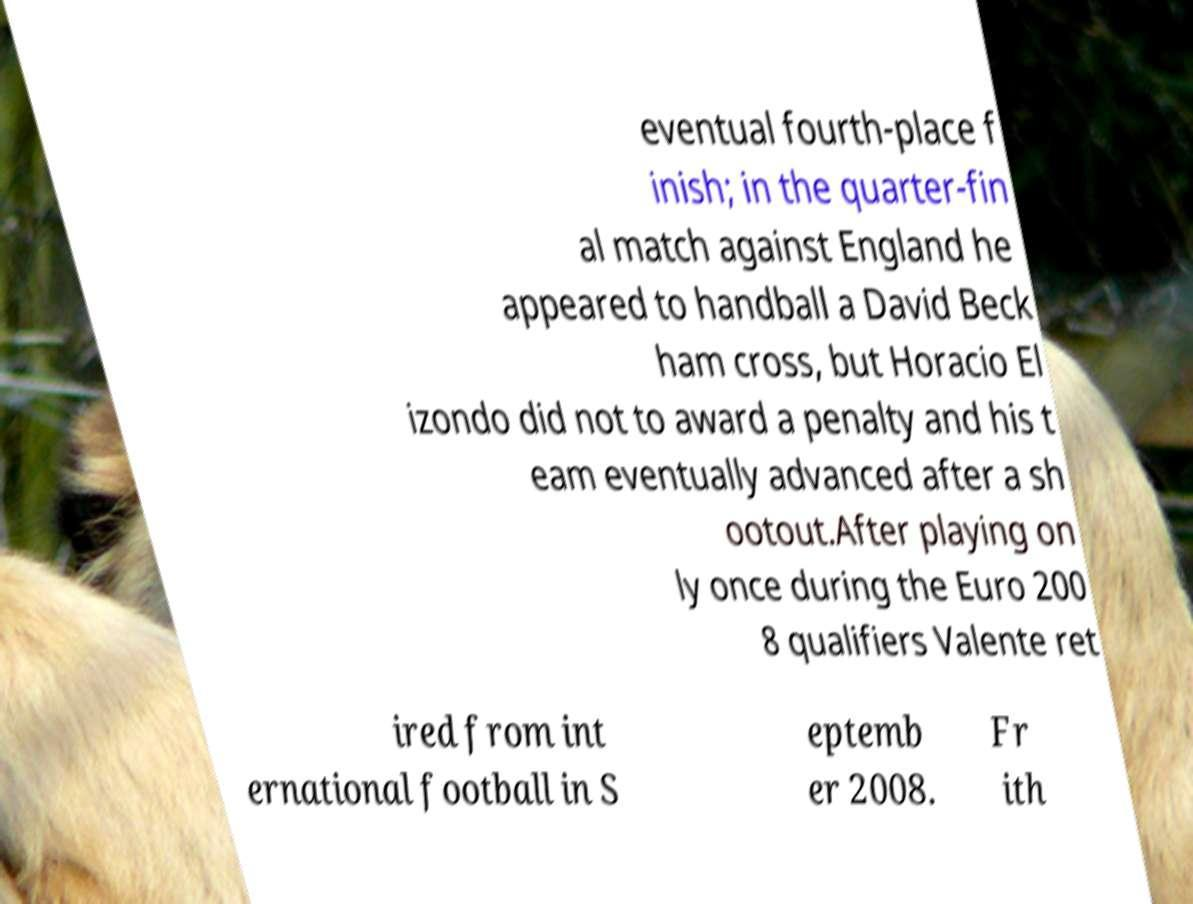Can you read and provide the text displayed in the image?This photo seems to have some interesting text. Can you extract and type it out for me? eventual fourth-place f inish; in the quarter-fin al match against England he appeared to handball a David Beck ham cross, but Horacio El izondo did not to award a penalty and his t eam eventually advanced after a sh ootout.After playing on ly once during the Euro 200 8 qualifiers Valente ret ired from int ernational football in S eptemb er 2008. Fr ith 